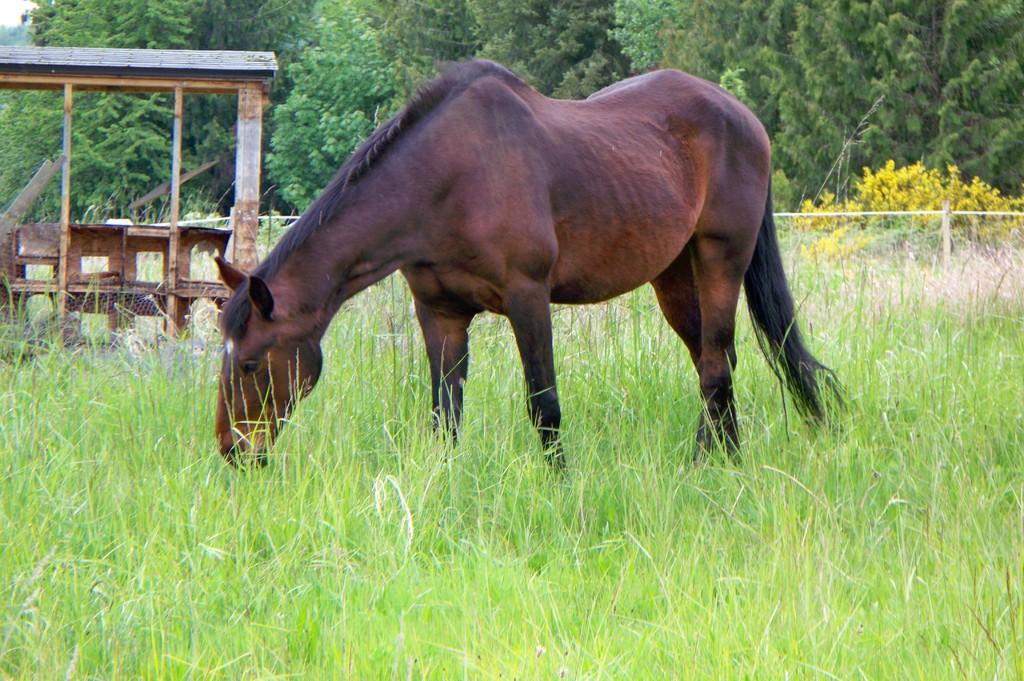What animal is the main subject of the image? There is a horse in the image. Where is the horse located in the image? The horse is standing on the grass. What can be seen in the background of the image? There is a shelter, plants, trees, and the sky visible in the background of the image. What type of territory does the horse claim as its own in the image? The image does not provide information about the horse's territory or any claim it might make. 